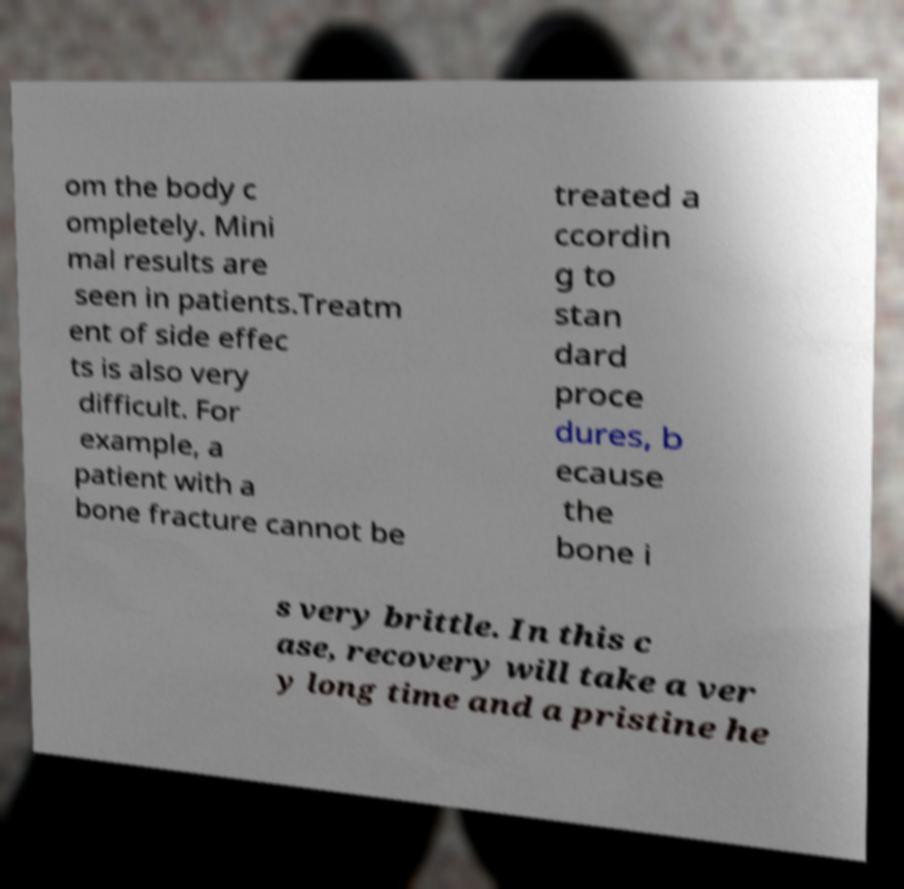Could you extract and type out the text from this image? om the body c ompletely. Mini mal results are seen in patients.Treatm ent of side effec ts is also very difficult. For example, a patient with a bone fracture cannot be treated a ccordin g to stan dard proce dures, b ecause the bone i s very brittle. In this c ase, recovery will take a ver y long time and a pristine he 